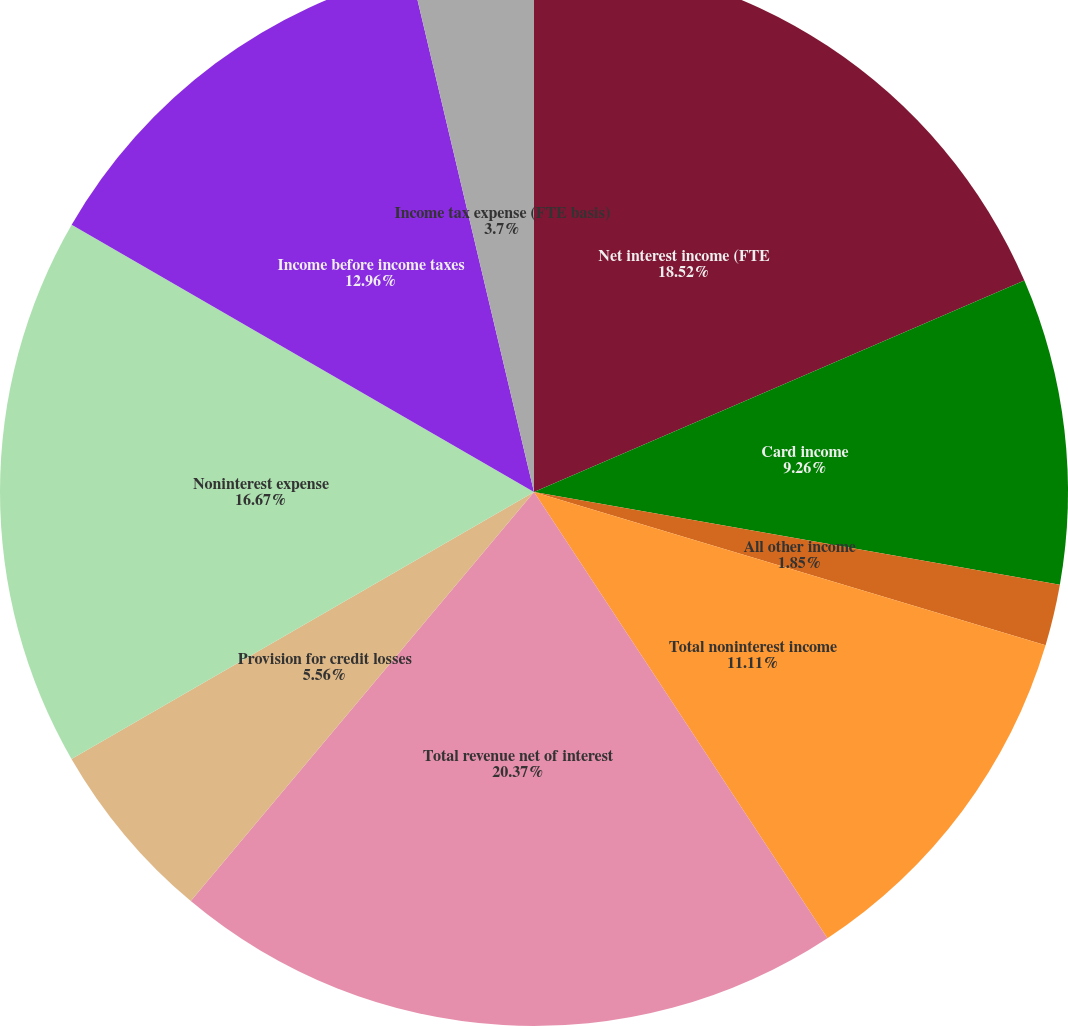<chart> <loc_0><loc_0><loc_500><loc_500><pie_chart><fcel>Net interest income (FTE<fcel>Card income<fcel>Service charges<fcel>All other income<fcel>Total noninterest income<fcel>Total revenue net of interest<fcel>Provision for credit losses<fcel>Noninterest expense<fcel>Income before income taxes<fcel>Income tax expense (FTE basis)<nl><fcel>18.52%<fcel>9.26%<fcel>0.0%<fcel>1.85%<fcel>11.11%<fcel>20.37%<fcel>5.56%<fcel>16.67%<fcel>12.96%<fcel>3.7%<nl></chart> 